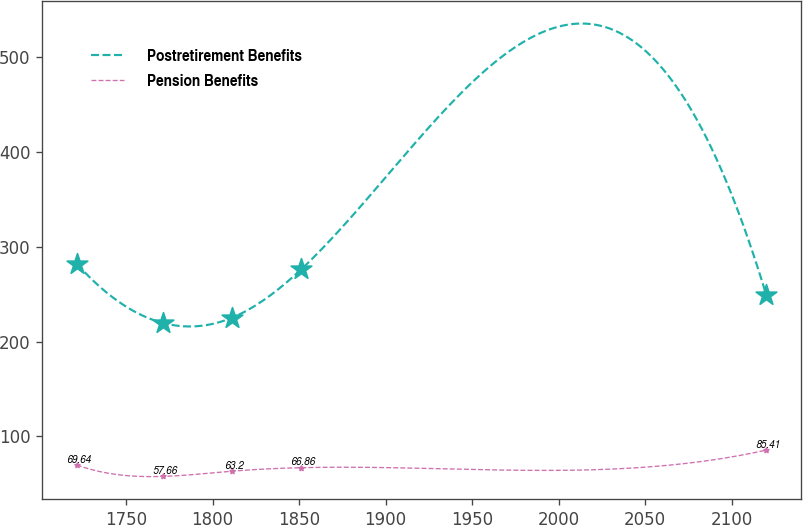<chart> <loc_0><loc_0><loc_500><loc_500><line_chart><ecel><fcel>Postretirement Benefits<fcel>Pension Benefits<nl><fcel>1721.59<fcel>282.06<fcel>69.64<nl><fcel>1771.58<fcel>219.49<fcel>57.66<nl><fcel>1811.42<fcel>225.28<fcel>63.2<nl><fcel>1851.26<fcel>276.26<fcel>66.86<nl><fcel>2119.97<fcel>249.09<fcel>85.41<nl></chart> 